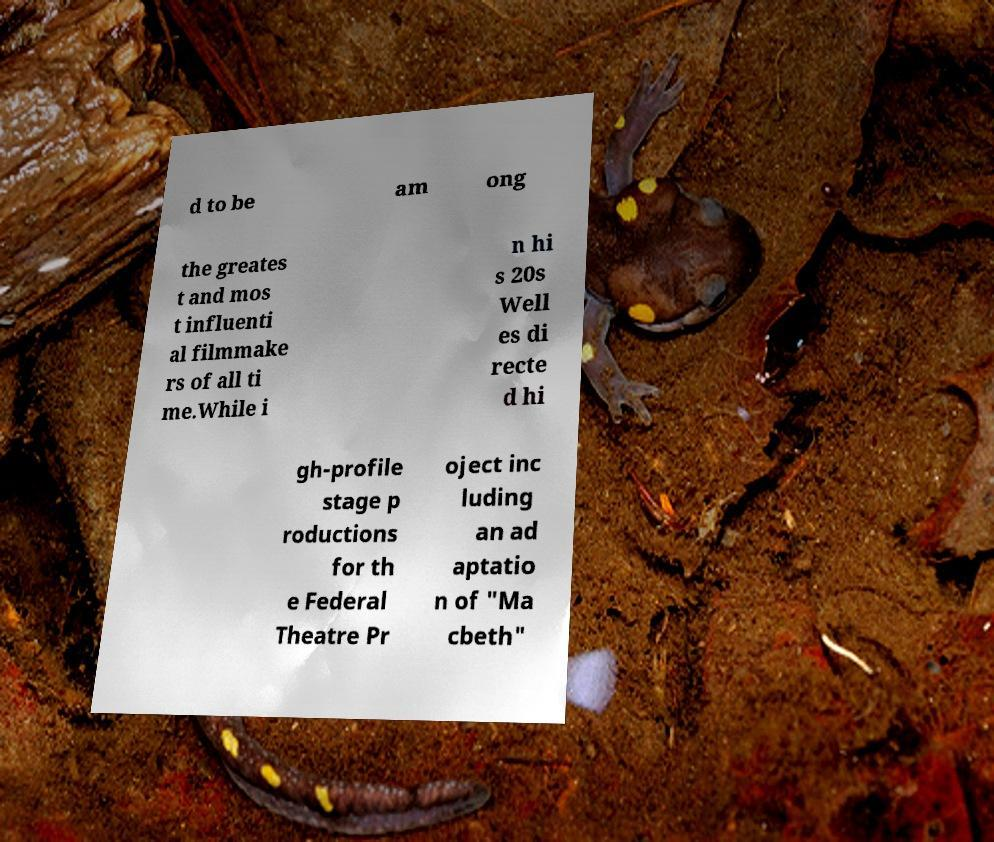I need the written content from this picture converted into text. Can you do that? d to be am ong the greates t and mos t influenti al filmmake rs of all ti me.While i n hi s 20s Well es di recte d hi gh-profile stage p roductions for th e Federal Theatre Pr oject inc luding an ad aptatio n of "Ma cbeth" 